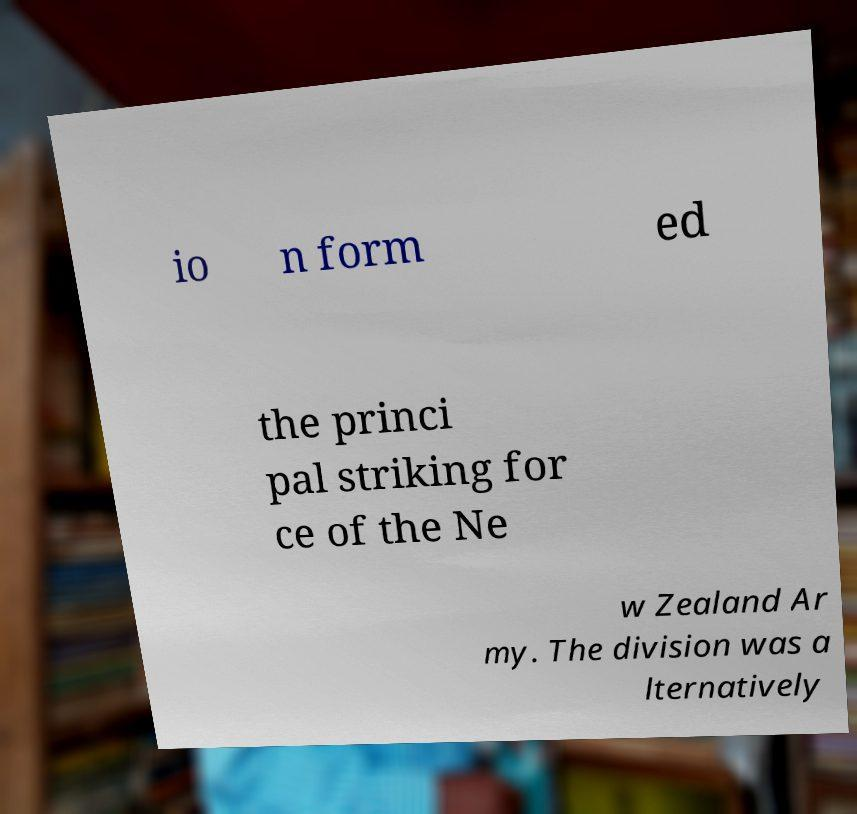Can you accurately transcribe the text from the provided image for me? io n form ed the princi pal striking for ce of the Ne w Zealand Ar my. The division was a lternatively 